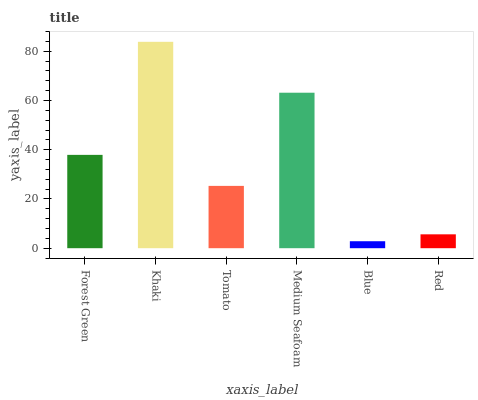Is Blue the minimum?
Answer yes or no. Yes. Is Khaki the maximum?
Answer yes or no. Yes. Is Tomato the minimum?
Answer yes or no. No. Is Tomato the maximum?
Answer yes or no. No. Is Khaki greater than Tomato?
Answer yes or no. Yes. Is Tomato less than Khaki?
Answer yes or no. Yes. Is Tomato greater than Khaki?
Answer yes or no. No. Is Khaki less than Tomato?
Answer yes or no. No. Is Forest Green the high median?
Answer yes or no. Yes. Is Tomato the low median?
Answer yes or no. Yes. Is Medium Seafoam the high median?
Answer yes or no. No. Is Red the low median?
Answer yes or no. No. 